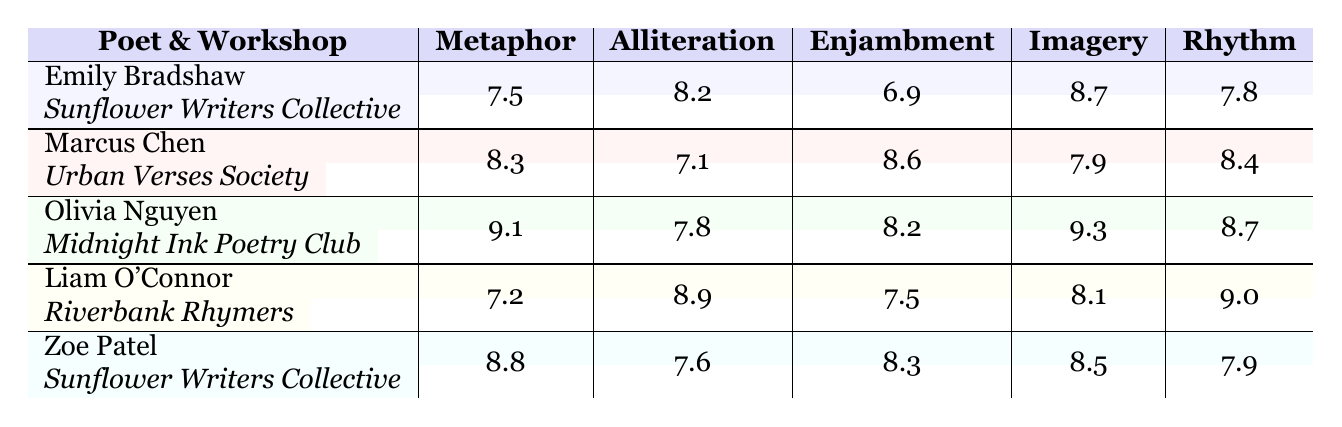What is the evaluation score for Imagery given to Zoe Patel? According to the table, Zoe Patel received a score of 8.5 for Imagery in the Sunflower Writers Collective workshop.
Answer: 8.5 Which poet received the highest score for Enjambment? Olivia Nguyen received the highest score for Enjambment with a score of 8.2 while attending the Midnight Ink Poetry Club workshop.
Answer: Olivia Nguyen What is the average score for Metaphor across all poets? To calculate the average score for Metaphor, sum the scores: 7.5 + 8.3 + 9.1 + 7.2 + 8.8 = 41.9. Then divide by the number of poets (5): 41.9 / 5 = 8.38.
Answer: 8.38 Did any poet receive a score of 9 or higher in any category? Yes, Olivia Nguyen received scores of 9.1 for Metaphor and 9.3 for Imagery, which are both 9 or higher.
Answer: Yes Which workshop had the highest average score in Alliteration? To find the highest average score for Alliteration, calculate the averages of each workshop: Sunflower Writers Collective = (8.2 + 7.6) / 2 = 7.9; Urban Verses Society = 7.1; Midnight Ink Poetry Club = 7.8; Riverbank Rhymers = 8.9. Riverbank Rhymers has the highest average of 8.9 in Alliteration.
Answer: Riverbank Rhymers What is the score difference in Rhythm between Olivia Nguyen and Liam O'Connor? Olivia Nguyen scored 8.7 in Rhythm, while Liam O'Connor scored 9.0. The difference is 9.0 - 8.7 = 0.3.
Answer: 0.3 Which poet has the overall highest scores across all poetic techniques? Olivia Nguyen has the highest scores: 9.1 for Metaphor, 7.8 for Alliteration, 8.2 for Enjambment, 9.3 for Imagery, and 8.7 for Rhythm, totaling to 8.82 when averaged ((9.1 + 7.8 + 8.2 + 9.3 + 8.7) / 5 = 8.82).
Answer: Olivia Nguyen Is there a poet that excelled in Alliteration with a score above 8, and who are they? Yes, both Emily Bradshaw (8.2) and Liam O'Connor (8.9) excelled in Alliteration with scores above 8.
Answer: Yes, Emily Bradshaw and Liam O'Connor 